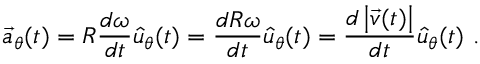Convert formula to latex. <formula><loc_0><loc_0><loc_500><loc_500>{ \vec { a } } _ { \theta } ( t ) = R { \frac { d \omega } { d t } } { \hat { u } } _ { \theta } ( t ) = { \frac { d R \omega } { d t } } { \hat { u } } _ { \theta } ( t ) = { \frac { d \left | { \vec { v } } ( t ) \right | } { d t } } { \hat { u } } _ { \theta } ( t ) \ .</formula> 